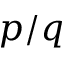Convert formula to latex. <formula><loc_0><loc_0><loc_500><loc_500>p / q</formula> 